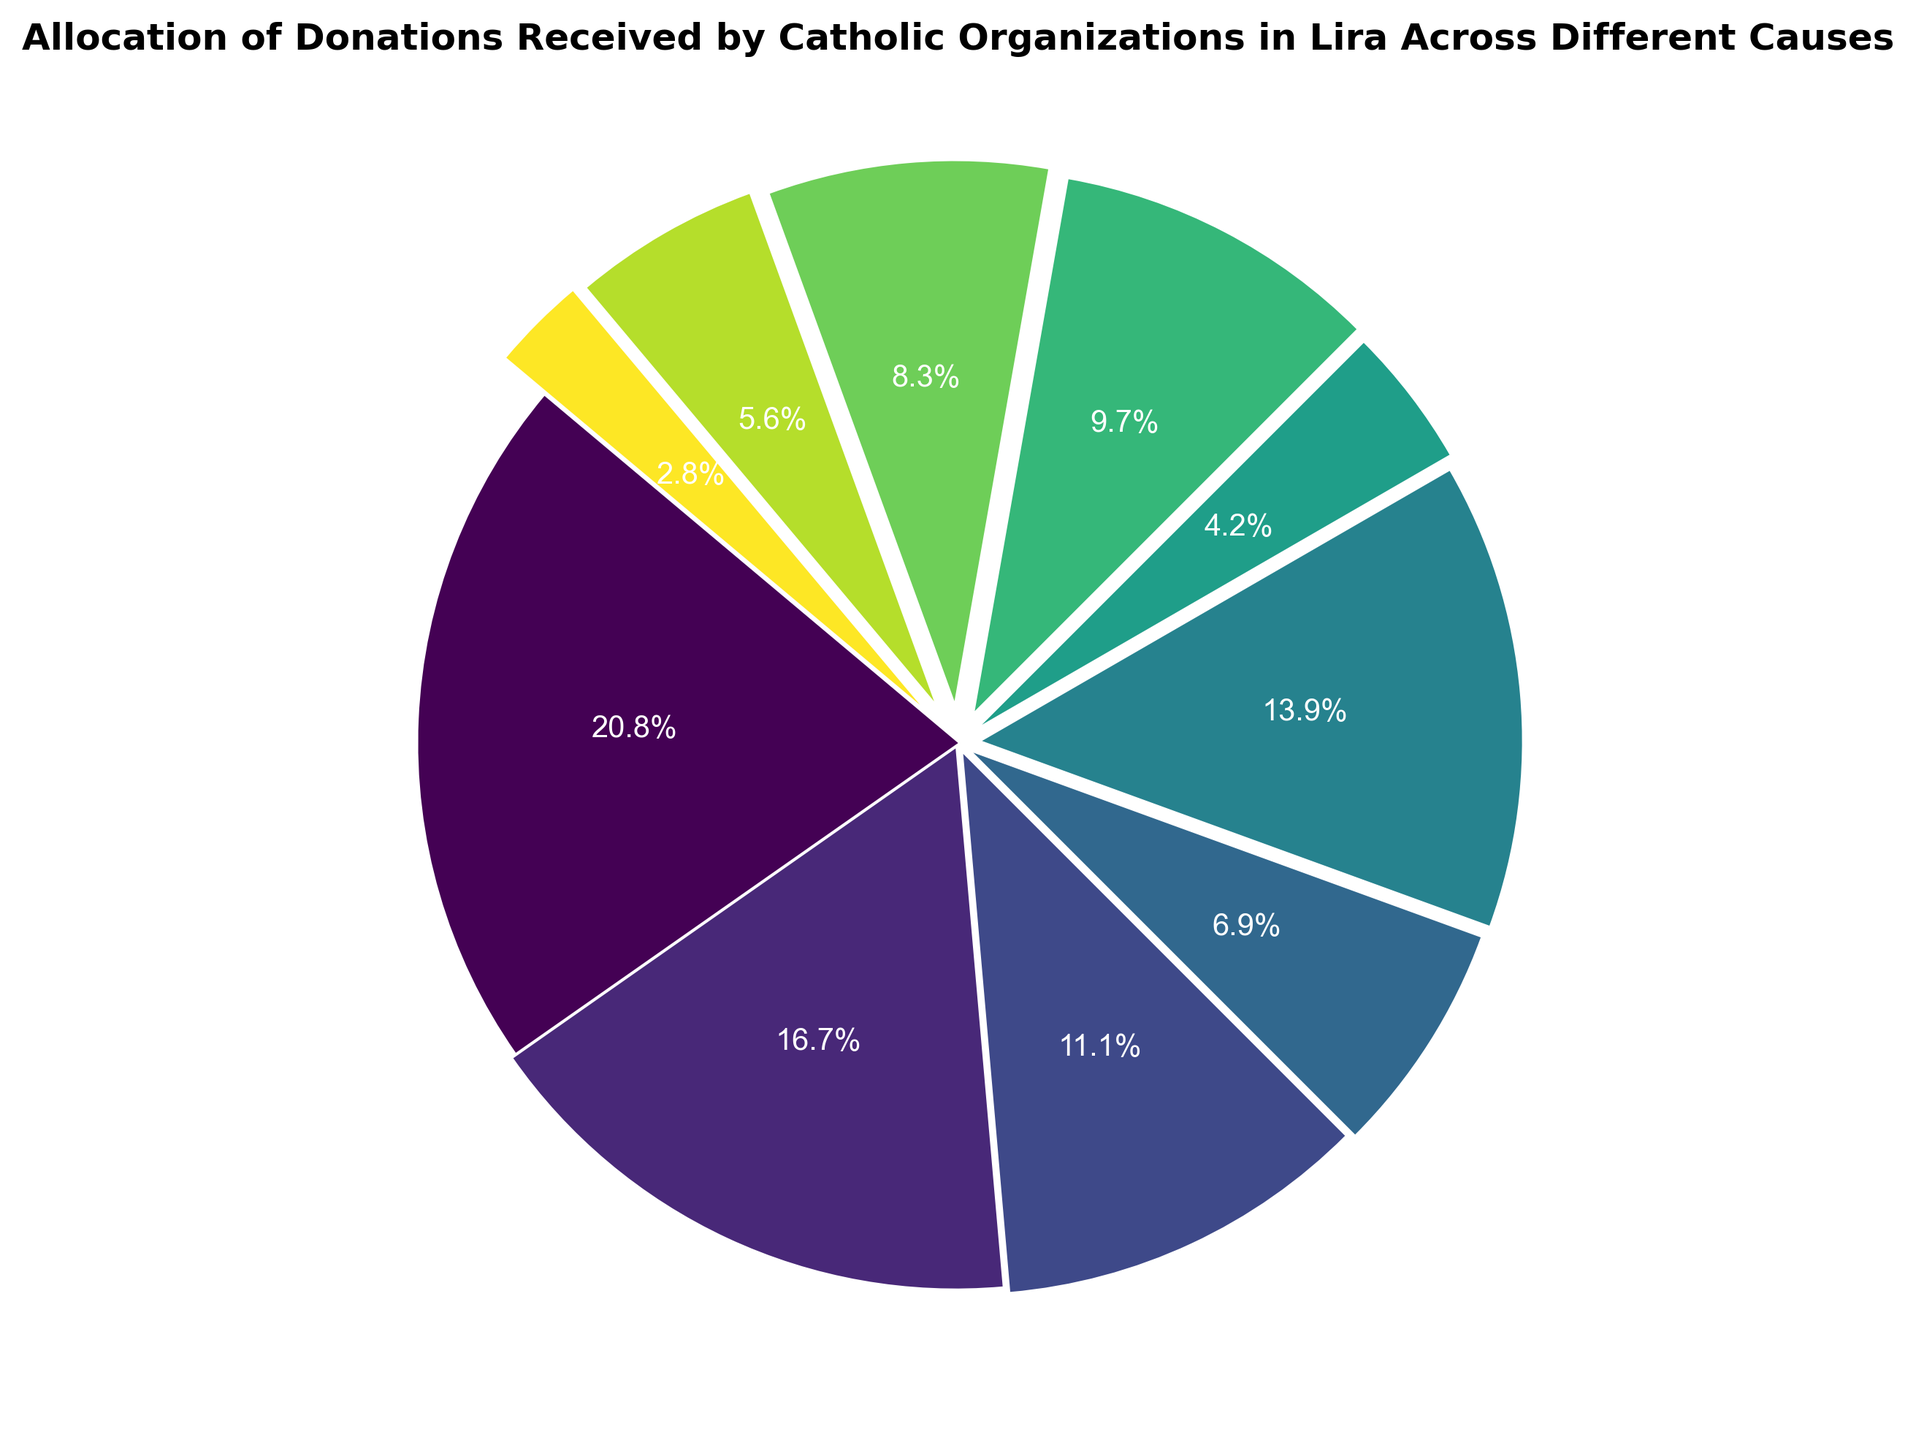Which cause received the highest donation? The figure shows different causes with their respective donation percentages. By identifying the segment with the largest share, we can determine the cause that received the highest donation.
Answer: Education What percentage of the total donations was allocated to healthcare? By looking at the pie chart, we can see the portion labeled "Healthcare" and the percentage associated with it.
Answer: 16.0% How do the donations for youth programs compare to those for orphanages? Look at the segments for "Youth Programs" and "Orphanages" and compare their respective percentages.
Answer: Youth Programs received more than Orphanages Are the donations for disaster relief higher or lower than those for mission trips? Identify the segments for "Disaster Relief" and "Mission Trips" and compare their sizes or percentages.
Answer: Higher What is the sum of donations allocated for community development and maintenance of church properties? Sum the donation amounts for "Community Development" ($8,000) and "Maintenance of Church Properties" ($7,000).
Answer: $15,000 What portion of the donations was allocated to religious activities compared to all other causes combined? Determine the percentage of the pie chart for "Religious Activities" and subtract this from 100% to see its proportion compared to all other causes.
Answer: Religious Activities is 13.3% of the total; remaining is 86.7% Which visual slice on the pie chart represents the smallest donation, and what is its cause? By identifying the smallest slice in the pie chart and checking its label, we can determine the cause with the smallest donation.
Answer: Mission Trips What is the difference in donation amounts between education and support for the elderly? Subtract the donation amount for "Support for the Elderly" ($4,000) from the donation amount for "Education" ($15,000).
Answer: $11,000 Do community development and youth programs together receive more donations than healthcare? Add the donations for "Community Development" ($8,000) and "Youth Programs" ($6,000), then compare the sum to the donation amount for "Healthcare" ($12,000).
Answer: Yes Which cause received a donation that is intermediate between the donations for religious activities and orphanages? Compare and find the donation amount that falls between $10,000 (Religious Activities) and $5,000 (Orphanages).
Answer: Maintenance of Church Properties 